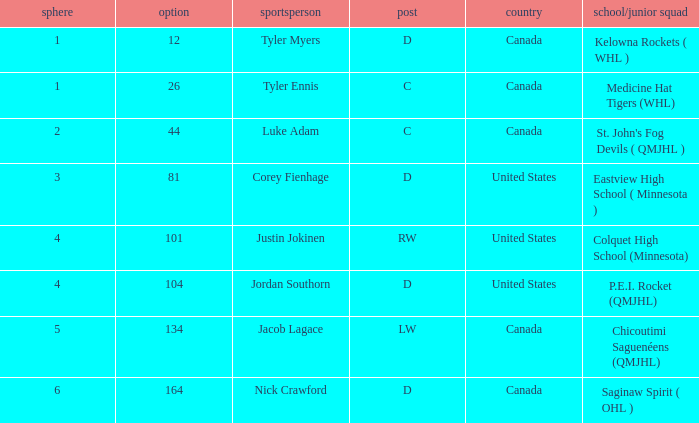What is the average round of the rw position player from the United States? 4.0. 